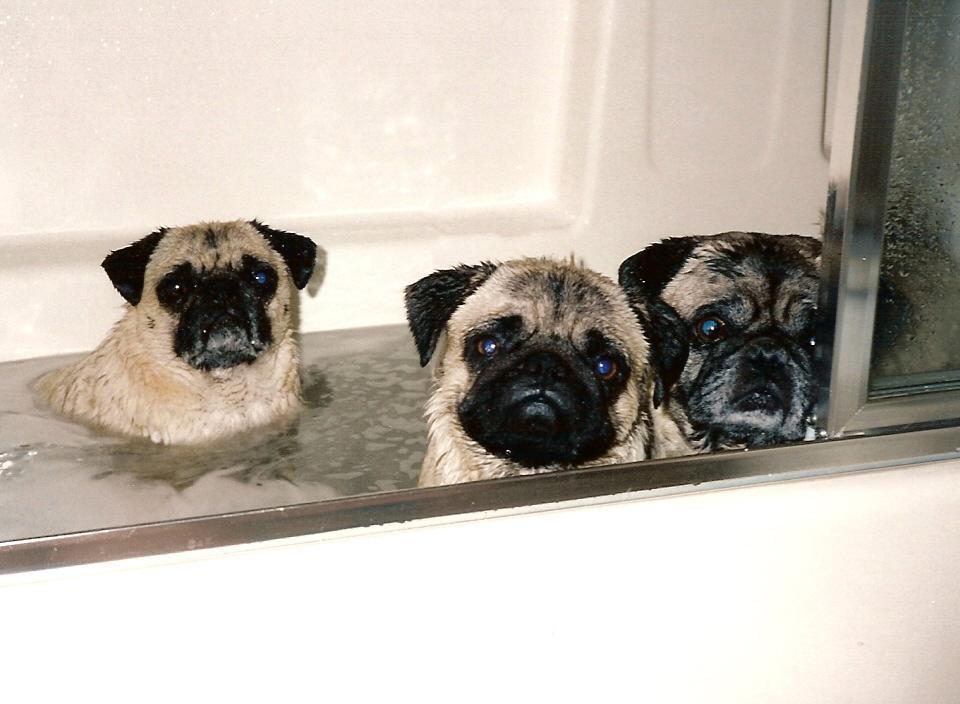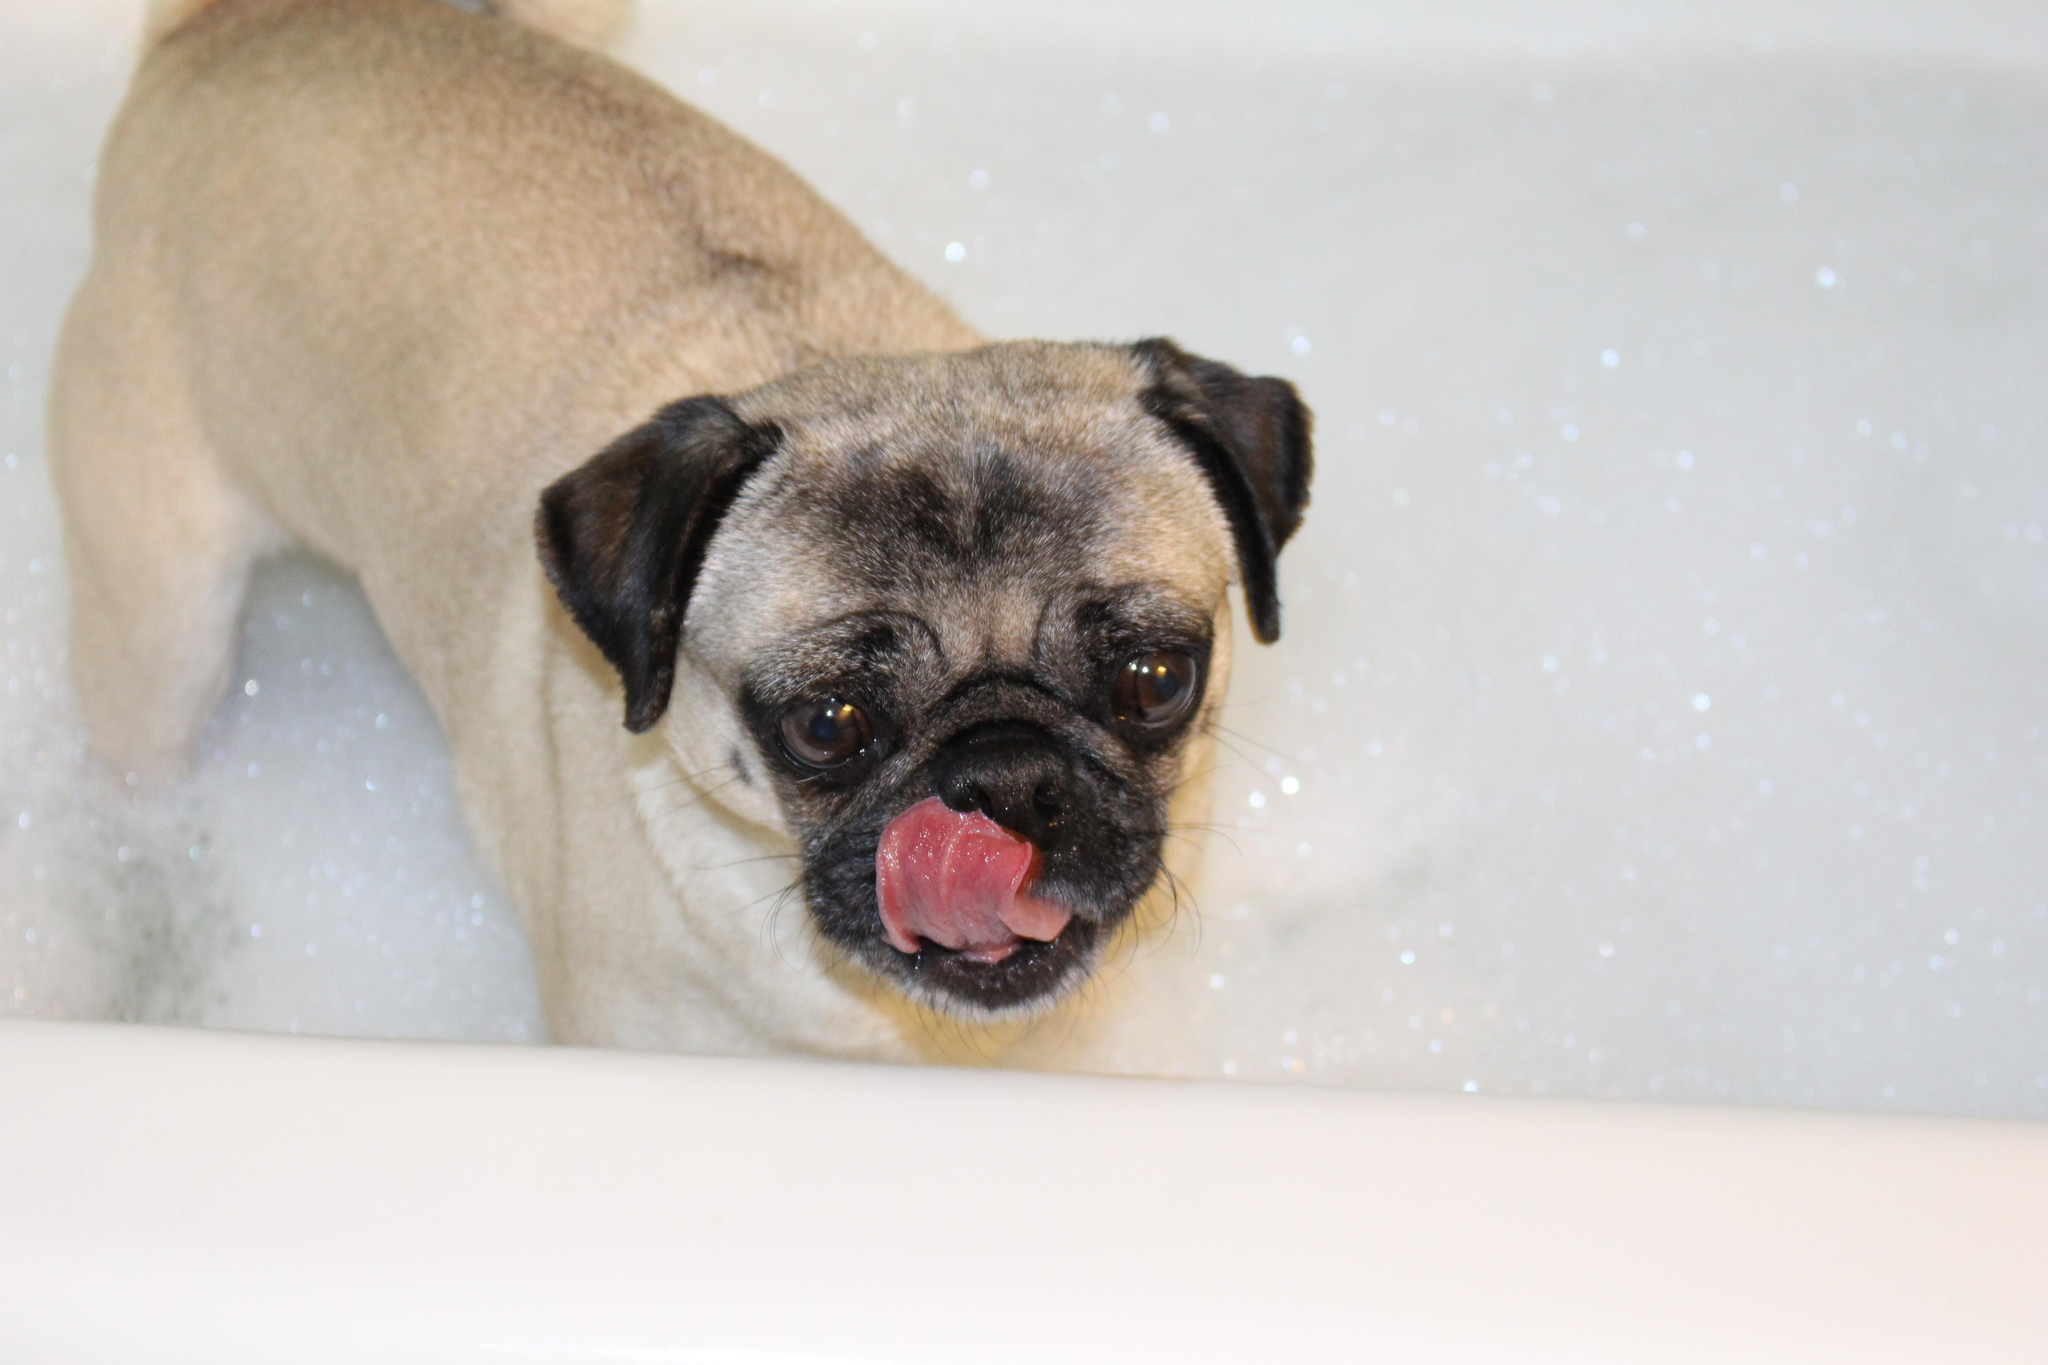The first image is the image on the left, the second image is the image on the right. For the images displayed, is the sentence "there are 4 dogs bathing in the image pair" factually correct? Answer yes or no. Yes. The first image is the image on the left, the second image is the image on the right. Analyze the images presented: Is the assertion "One dog has soap on his back." valid? Answer yes or no. No. 